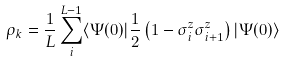Convert formula to latex. <formula><loc_0><loc_0><loc_500><loc_500>\rho _ { k } = \frac { 1 } { L } \sum _ { i } ^ { L - 1 } \langle \Psi ( 0 ) | \frac { 1 } { 2 } \left ( 1 - \sigma _ { i } ^ { z } \sigma _ { i + 1 } ^ { z } \right ) | \Psi ( 0 ) \rangle</formula> 